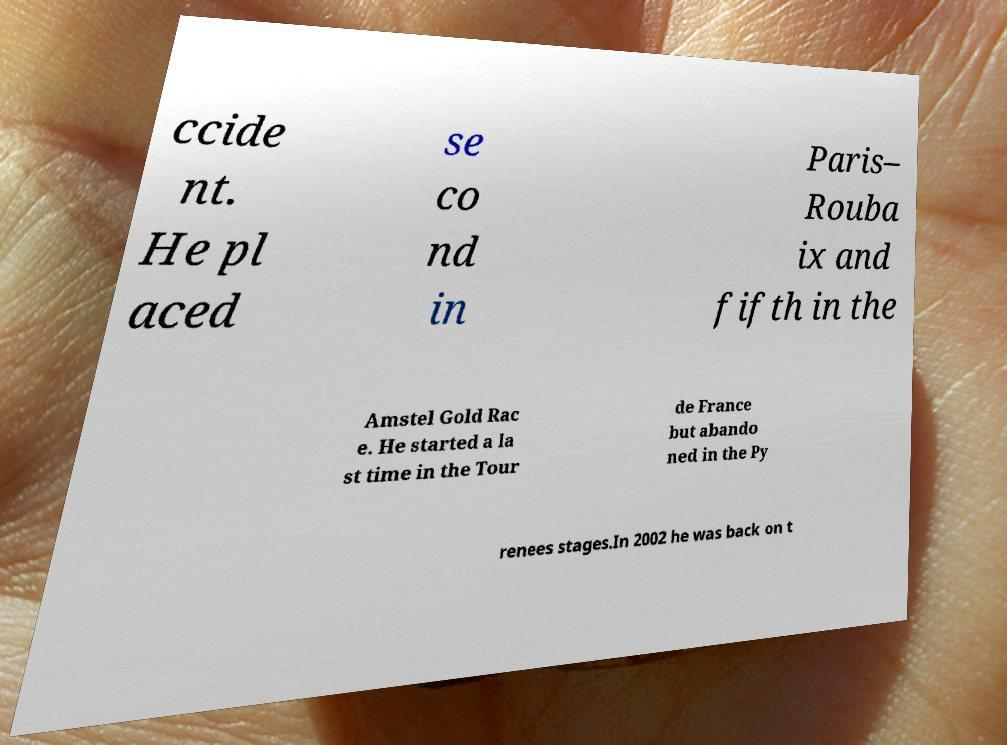Can you accurately transcribe the text from the provided image for me? ccide nt. He pl aced se co nd in Paris– Rouba ix and fifth in the Amstel Gold Rac e. He started a la st time in the Tour de France but abando ned in the Py renees stages.In 2002 he was back on t 